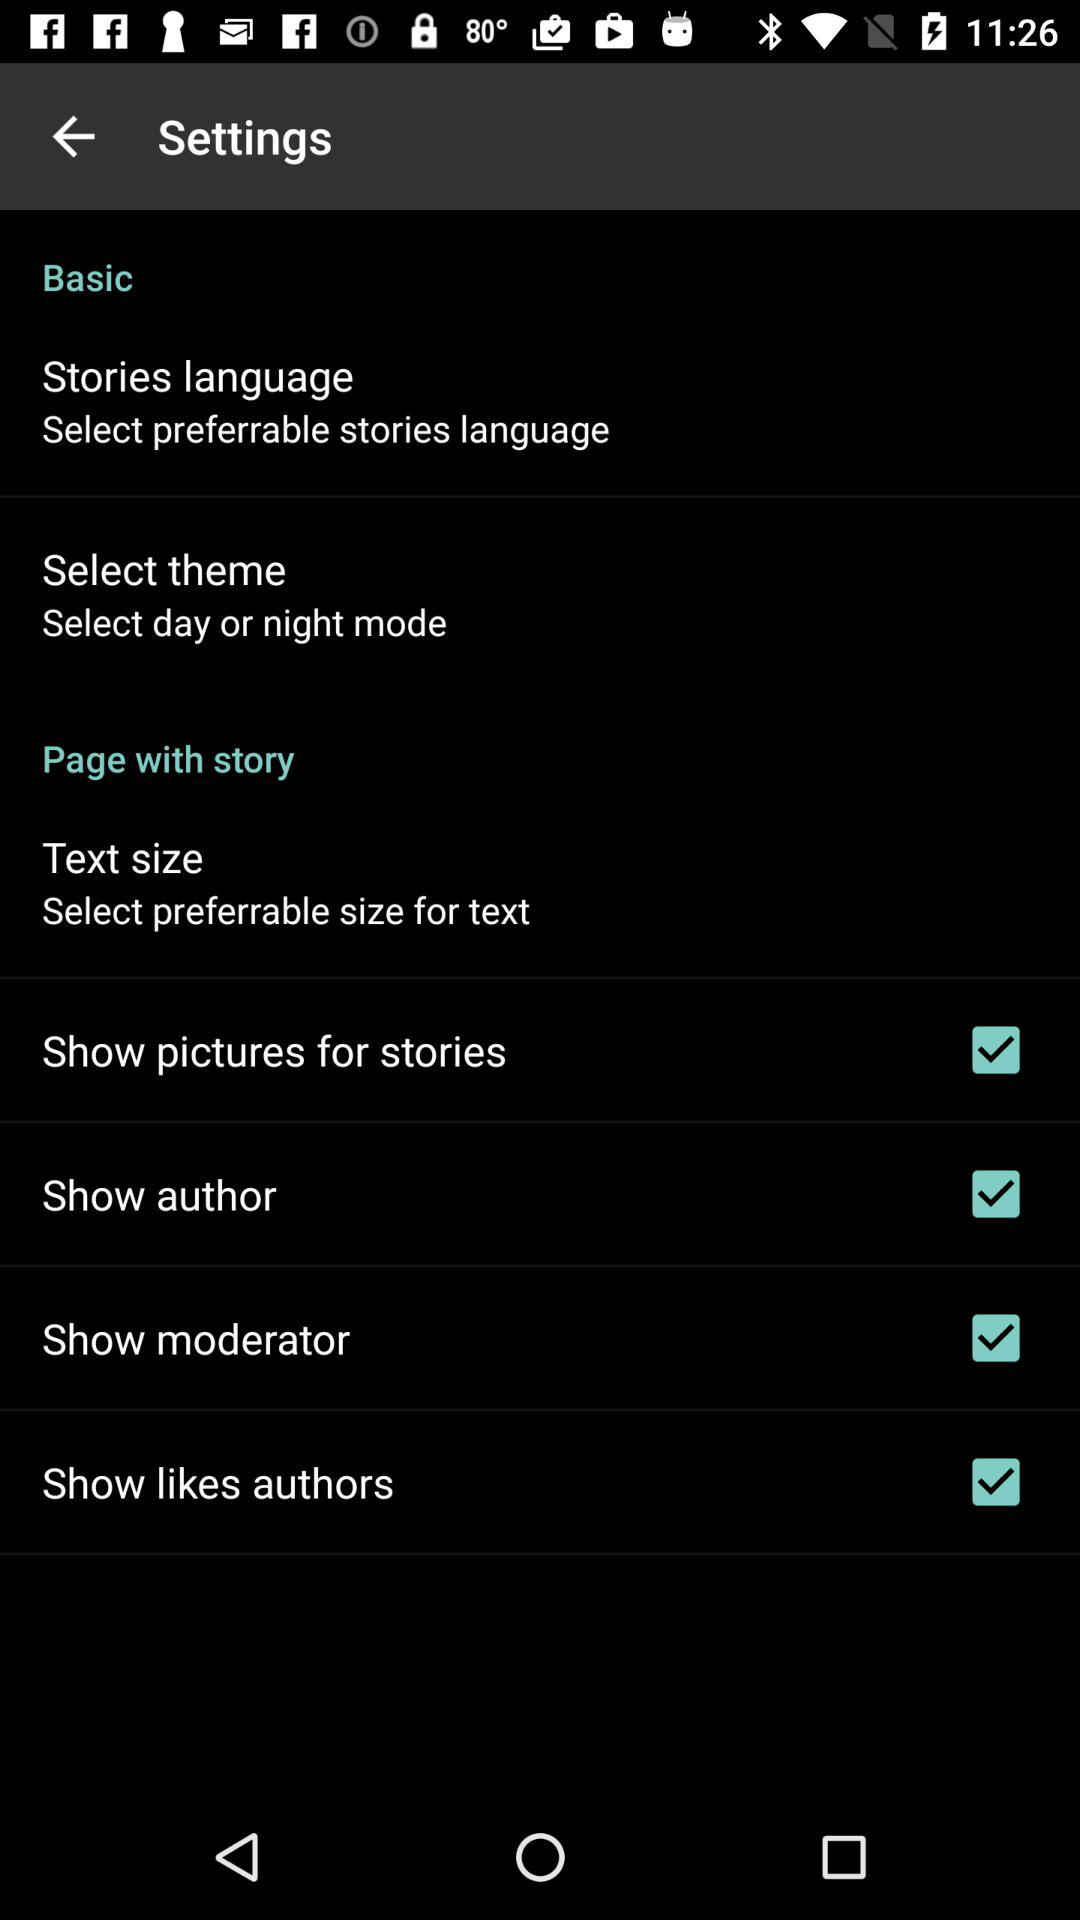What is the status of the "Show Moderator"? The status is "on". 